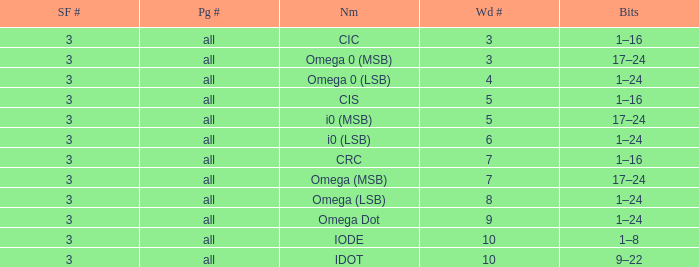What is the total word count with a subframe count greater than 3? None. 